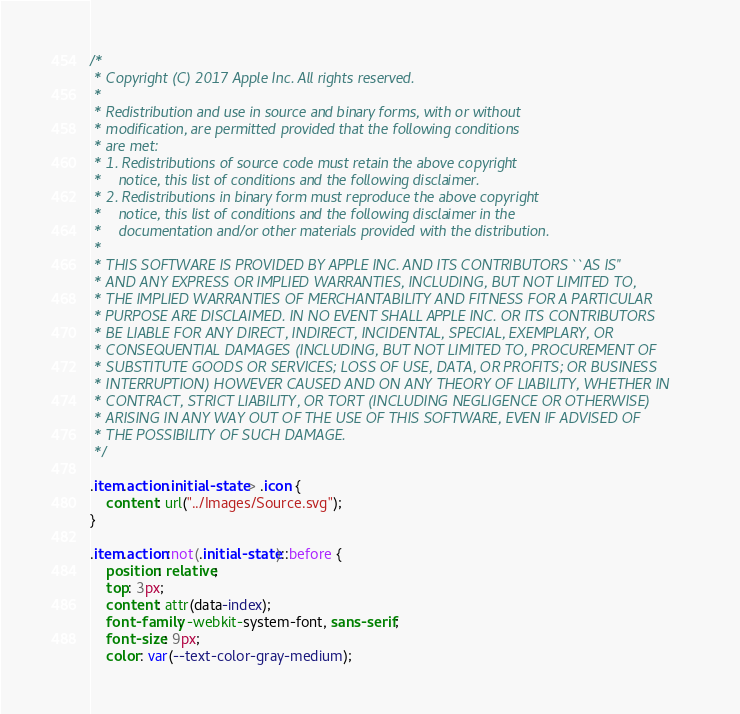<code> <loc_0><loc_0><loc_500><loc_500><_CSS_>/*
 * Copyright (C) 2017 Apple Inc. All rights reserved.
 *
 * Redistribution and use in source and binary forms, with or without
 * modification, are permitted provided that the following conditions
 * are met:
 * 1. Redistributions of source code must retain the above copyright
 *    notice, this list of conditions and the following disclaimer.
 * 2. Redistributions in binary form must reproduce the above copyright
 *    notice, this list of conditions and the following disclaimer in the
 *    documentation and/or other materials provided with the distribution.
 *
 * THIS SOFTWARE IS PROVIDED BY APPLE INC. AND ITS CONTRIBUTORS ``AS IS''
 * AND ANY EXPRESS OR IMPLIED WARRANTIES, INCLUDING, BUT NOT LIMITED TO,
 * THE IMPLIED WARRANTIES OF MERCHANTABILITY AND FITNESS FOR A PARTICULAR
 * PURPOSE ARE DISCLAIMED. IN NO EVENT SHALL APPLE INC. OR ITS CONTRIBUTORS
 * BE LIABLE FOR ANY DIRECT, INDIRECT, INCIDENTAL, SPECIAL, EXEMPLARY, OR
 * CONSEQUENTIAL DAMAGES (INCLUDING, BUT NOT LIMITED TO, PROCUREMENT OF
 * SUBSTITUTE GOODS OR SERVICES; LOSS OF USE, DATA, OR PROFITS; OR BUSINESS
 * INTERRUPTION) HOWEVER CAUSED AND ON ANY THEORY OF LIABILITY, WHETHER IN
 * CONTRACT, STRICT LIABILITY, OR TORT (INCLUDING NEGLIGENCE OR OTHERWISE)
 * ARISING IN ANY WAY OUT OF THE USE OF THIS SOFTWARE, EVEN IF ADVISED OF
 * THE POSSIBILITY OF SUCH DAMAGE.
 */

.item.action.initial-state > .icon {
    content: url("../Images/Source.svg");
}

.item.action:not(.initial-state)::before {
    position: relative;
    top: 3px;
    content: attr(data-index);
    font-family: -webkit-system-font, sans-serif;
    font-size: 9px;
    color: var(--text-color-gray-medium);</code> 